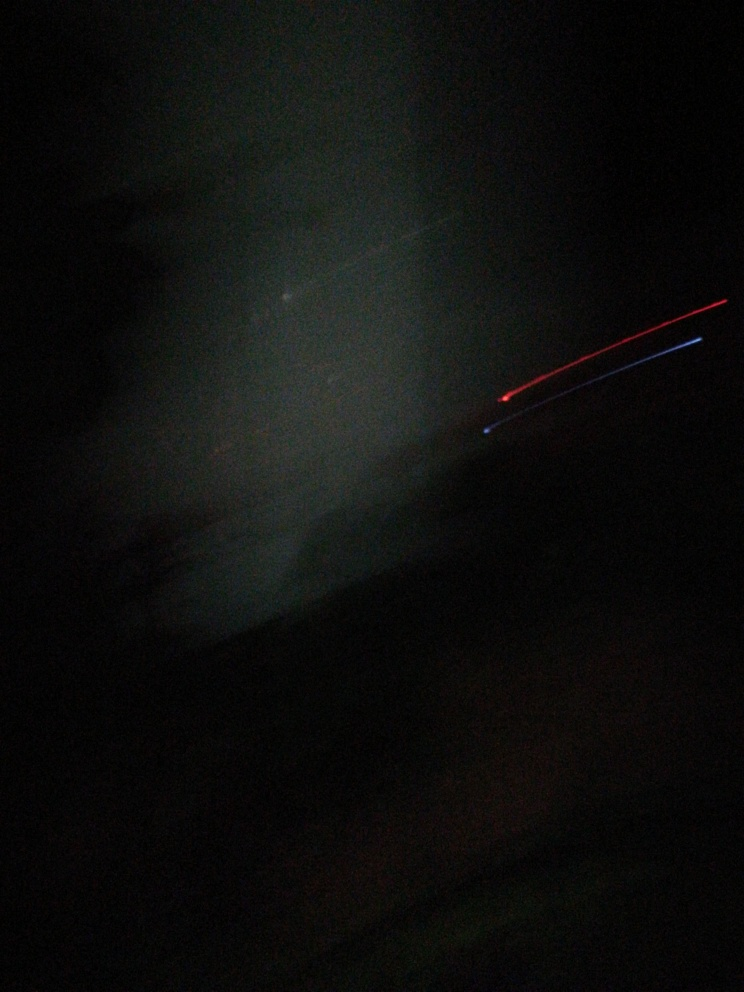Is the exposure too dark in this image? Based on the image provided, it appears that the exposure is indeed quite dark, which limits the visibility of details. It might be intentional for aesthetic reasons or due to low lighting conditions when the photograph was taken. Enhancing the brightness and contrast could reveal more details. 